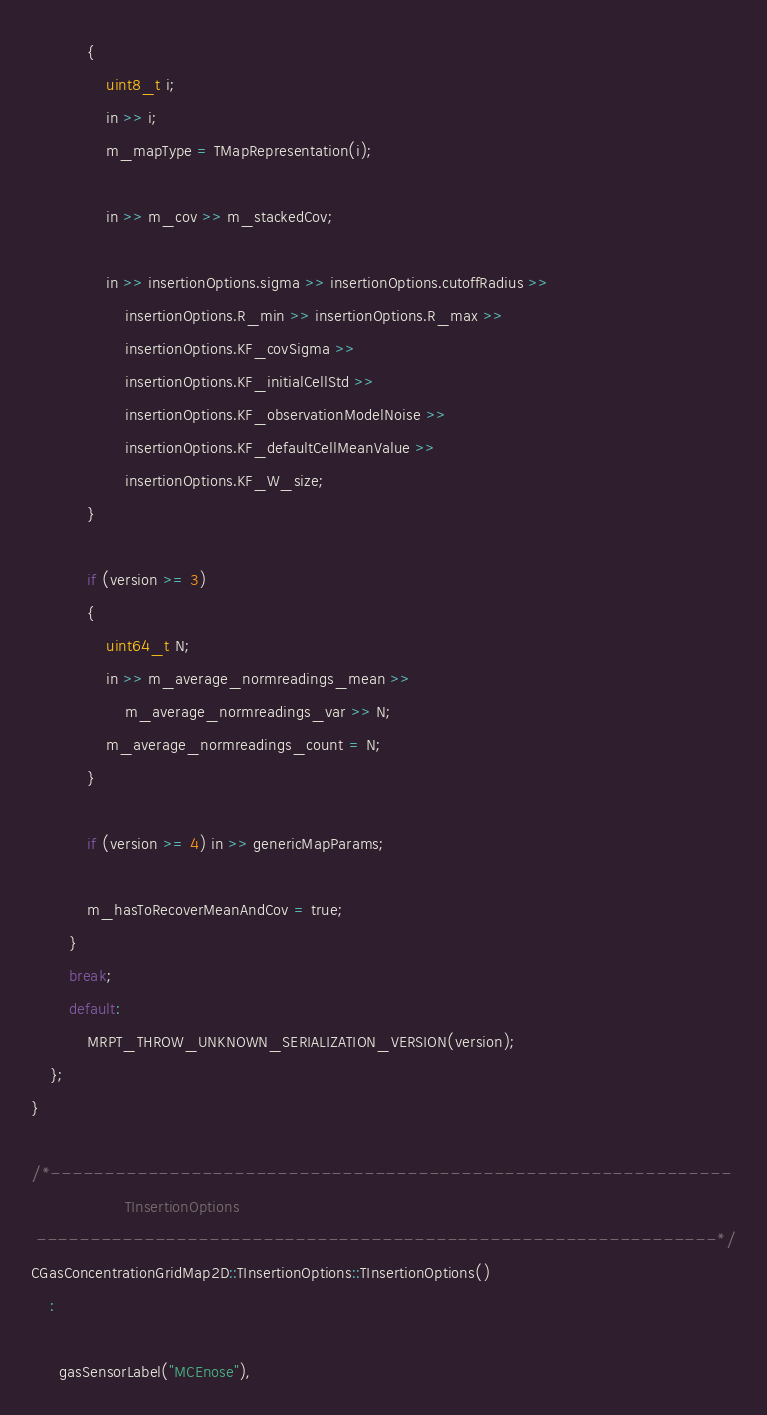Convert code to text. <code><loc_0><loc_0><loc_500><loc_500><_C++_>			{
				uint8_t i;
				in >> i;
				m_mapType = TMapRepresentation(i);

				in >> m_cov >> m_stackedCov;

				in >> insertionOptions.sigma >> insertionOptions.cutoffRadius >>
					insertionOptions.R_min >> insertionOptions.R_max >>
					insertionOptions.KF_covSigma >>
					insertionOptions.KF_initialCellStd >>
					insertionOptions.KF_observationModelNoise >>
					insertionOptions.KF_defaultCellMeanValue >>
					insertionOptions.KF_W_size;
			}

			if (version >= 3)
			{
				uint64_t N;
				in >> m_average_normreadings_mean >>
					m_average_normreadings_var >> N;
				m_average_normreadings_count = N;
			}

			if (version >= 4) in >> genericMapParams;

			m_hasToRecoverMeanAndCov = true;
		}
		break;
		default:
			MRPT_THROW_UNKNOWN_SERIALIZATION_VERSION(version);
	};
}

/*---------------------------------------------------------------
					TInsertionOptions
 ---------------------------------------------------------------*/
CGasConcentrationGridMap2D::TInsertionOptions::TInsertionOptions()
	:

	  gasSensorLabel("MCEnose"),</code> 